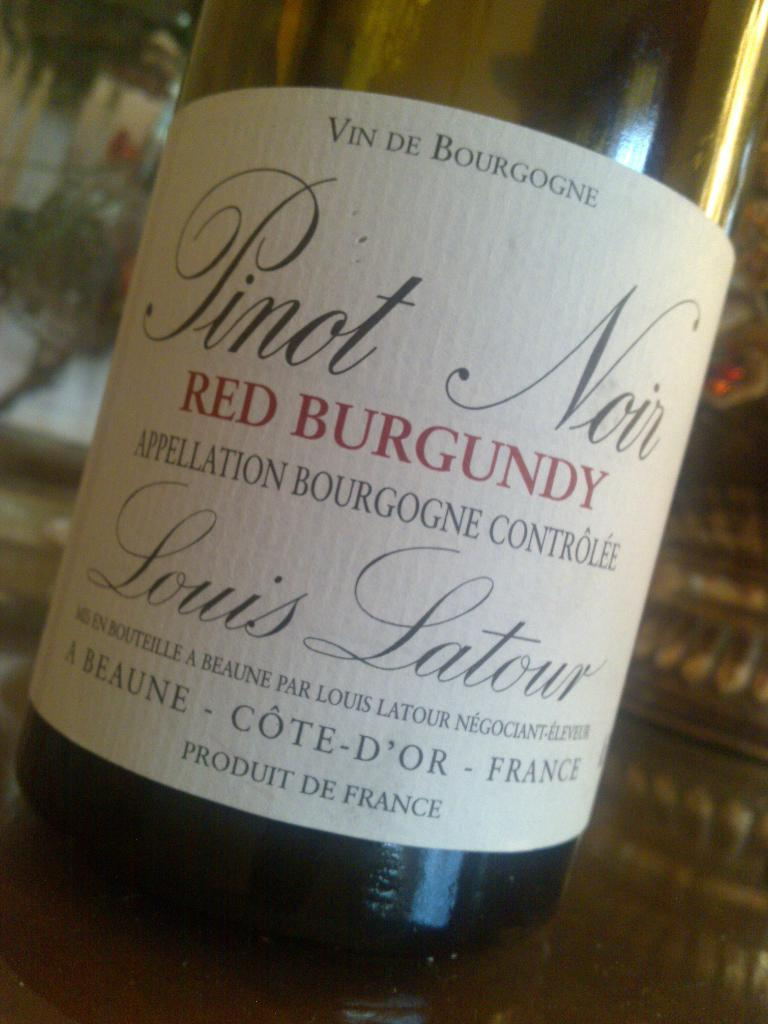<image>
Render a clear and concise summary of the photo. A bottle of Pinot Noir Red Burgundy Produit De France. 